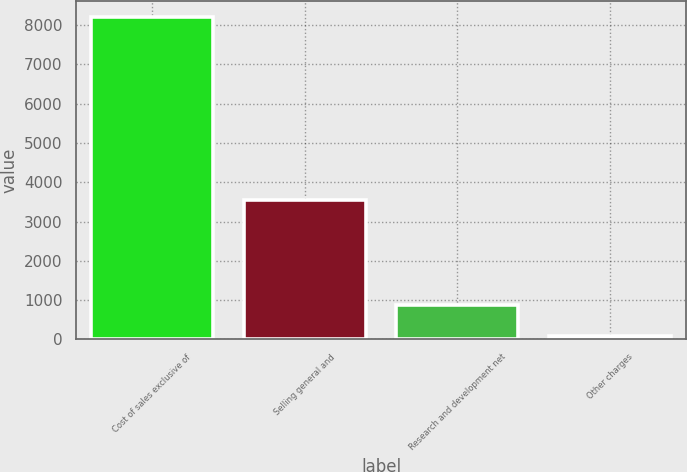Convert chart to OTSL. <chart><loc_0><loc_0><loc_500><loc_500><bar_chart><fcel>Cost of sales exclusive of<fcel>Selling general and<fcel>Research and development net<fcel>Other charges<nl><fcel>8209<fcel>3554<fcel>887.5<fcel>74<nl></chart> 